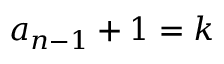Convert formula to latex. <formula><loc_0><loc_0><loc_500><loc_500>a _ { n - 1 } + 1 = k</formula> 